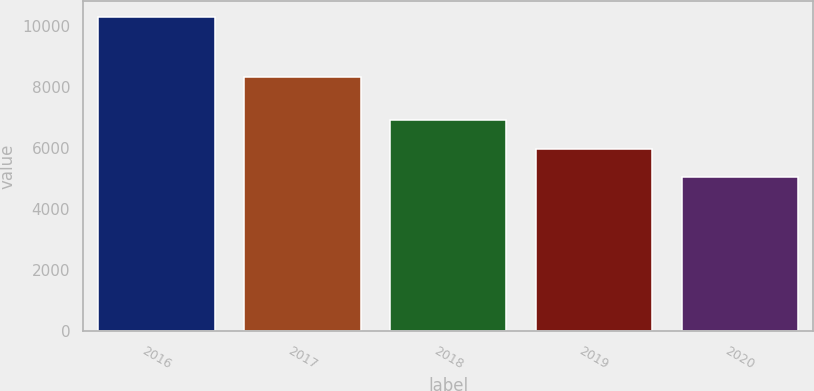<chart> <loc_0><loc_0><loc_500><loc_500><bar_chart><fcel>2016<fcel>2017<fcel>2018<fcel>2019<fcel>2020<nl><fcel>10293<fcel>8309<fcel>6899<fcel>5947<fcel>5055<nl></chart> 